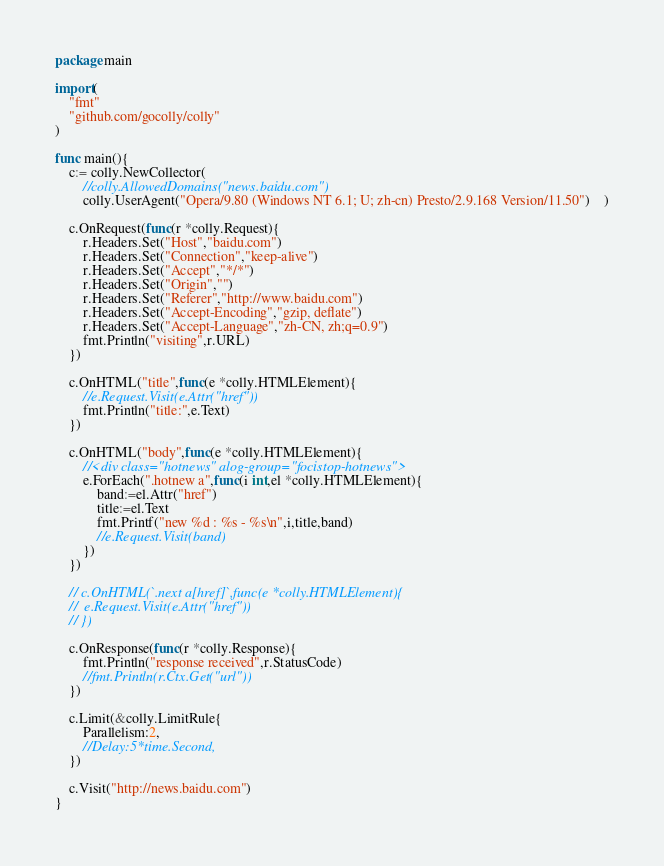Convert code to text. <code><loc_0><loc_0><loc_500><loc_500><_Go_>package main

import(
	"fmt"
	"github.com/gocolly/colly"
)

func main(){
	c:= colly.NewCollector(
		//colly.AllowedDomains("news.baidu.com")
		colly.UserAgent("Opera/9.80 (Windows NT 6.1; U; zh-cn) Presto/2.9.168 Version/11.50")	)

	c.OnRequest(func(r *colly.Request){
		r.Headers.Set("Host","baidu.com")
		r.Headers.Set("Connection","keep-alive")
		r.Headers.Set("Accept","*/*")
		r.Headers.Set("Origin","")
		r.Headers.Set("Referer","http://www.baidu.com")
		r.Headers.Set("Accept-Encoding","gzip, deflate")
		r.Headers.Set("Accept-Language","zh-CN, zh;q=0.9")
		fmt.Println("visiting",r.URL)
	})

	c.OnHTML("title",func(e *colly.HTMLElement){
		//e.Request.Visit(e.Attr("href"))
		fmt.Println("title:",e.Text)
	})

	c.OnHTML("body",func(e *colly.HTMLElement){
		//<div class="hotnews" alog-group="focistop-hotnews">
		e.ForEach(".hotnew a",func(i int,el *colly.HTMLElement){
			band:=el.Attr("href")
			title:=el.Text
			fmt.Printf("new %d : %s - %s\n",i,title,band)
			//e.Request.Visit(band)
		})
	})

	// c.OnHTML(`.next a[href]`,func(e *colly.HTMLElement){
	// 	e.Request.Visit(e.Attr("href"))
	// })

	c.OnResponse(func(r *colly.Response){
		fmt.Println("response received",r.StatusCode)
		//fmt.Println(r.Ctx.Get("url"))
	})

	c.Limit(&colly.LimitRule{
		Parallelism:2,
		//Delay:5*time.Second,
	})

	c.Visit("http://news.baidu.com")
}</code> 